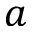Convert formula to latex. <formula><loc_0><loc_0><loc_500><loc_500>a</formula> 